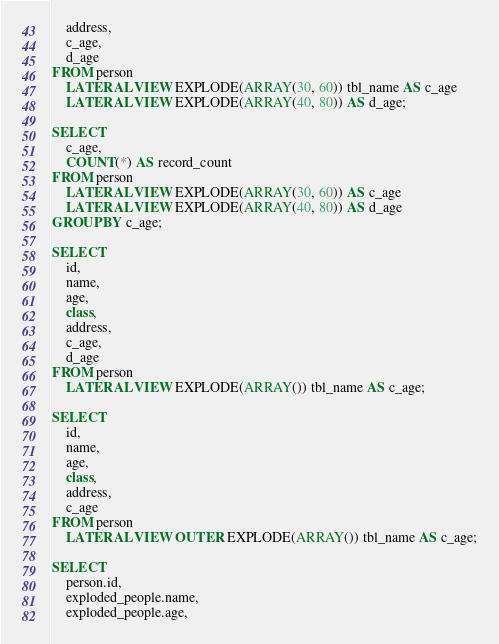Convert code to text. <code><loc_0><loc_0><loc_500><loc_500><_SQL_>    address,
    c_age,
    d_age
FROM person
    LATERAL VIEW EXPLODE(ARRAY(30, 60)) tbl_name AS c_age
    LATERAL VIEW EXPLODE(ARRAY(40, 80)) AS d_age;

SELECT
    c_age,
    COUNT(*) AS record_count
FROM person
    LATERAL VIEW EXPLODE(ARRAY(30, 60)) AS c_age
    LATERAL VIEW EXPLODE(ARRAY(40, 80)) AS d_age
GROUP BY c_age;

SELECT
    id,
    name,
    age,
    class,
    address,
    c_age,
    d_age
FROM person
    LATERAL VIEW EXPLODE(ARRAY()) tbl_name AS c_age;

SELECT
    id,
    name,
    age,
    class,
    address,
    c_age
FROM person
    LATERAL VIEW OUTER EXPLODE(ARRAY()) tbl_name AS c_age;

SELECT
    person.id,
    exploded_people.name,
    exploded_people.age,</code> 